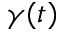Convert formula to latex. <formula><loc_0><loc_0><loc_500><loc_500>\gamma ( t )</formula> 